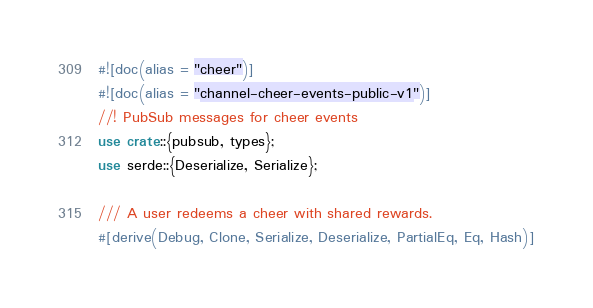<code> <loc_0><loc_0><loc_500><loc_500><_Rust_>#![doc(alias = "cheer")]
#![doc(alias = "channel-cheer-events-public-v1")]
//! PubSub messages for cheer events
use crate::{pubsub, types};
use serde::{Deserialize, Serialize};

/// A user redeems a cheer with shared rewards.
#[derive(Debug, Clone, Serialize, Deserialize, PartialEq, Eq, Hash)]</code> 